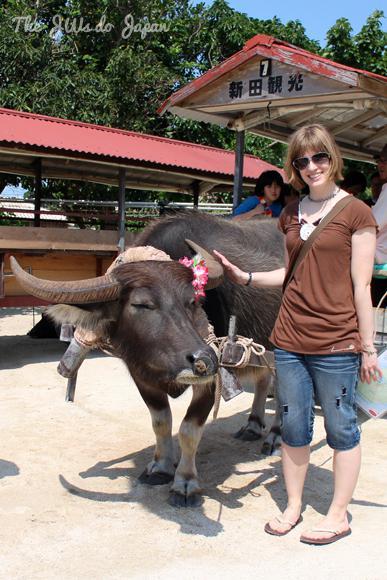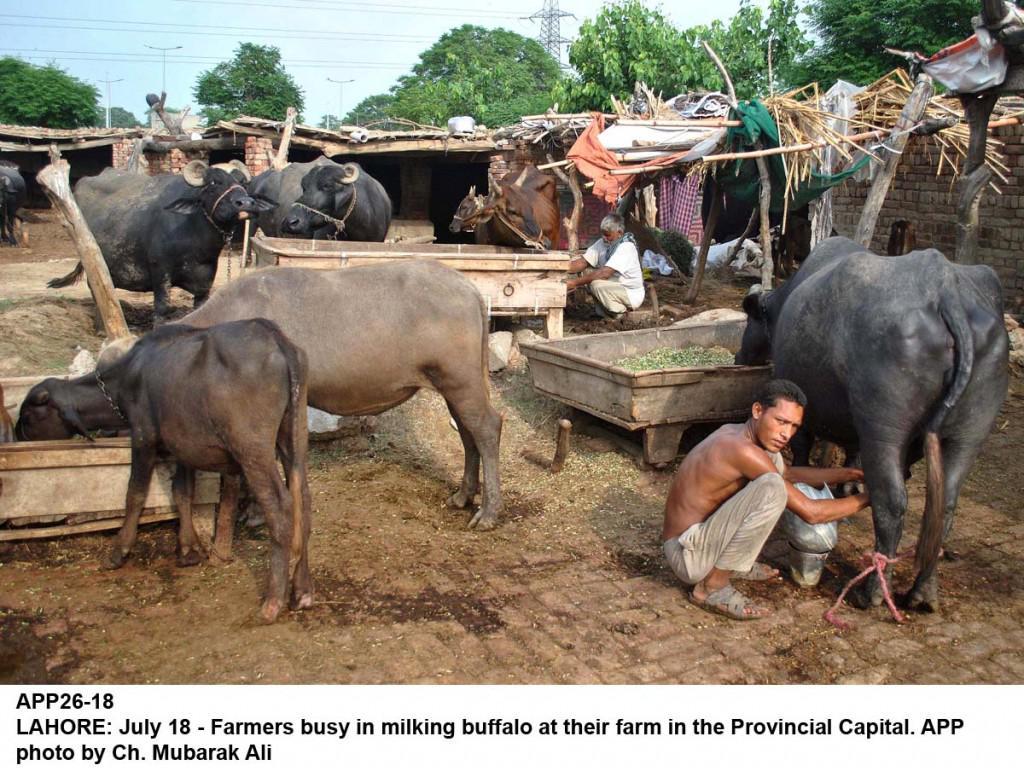The first image is the image on the left, the second image is the image on the right. For the images displayed, is the sentence "An image shows at least one person walking rightward with at least one ox that is not hitched to any wagon." factually correct? Answer yes or no. No. 